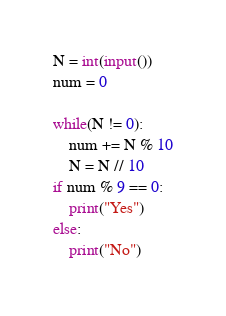<code> <loc_0><loc_0><loc_500><loc_500><_Python_>N = int(input())
num = 0

while(N != 0):
    num += N % 10
    N = N // 10
if num % 9 == 0:
    print("Yes")
else:
    print("No")</code> 